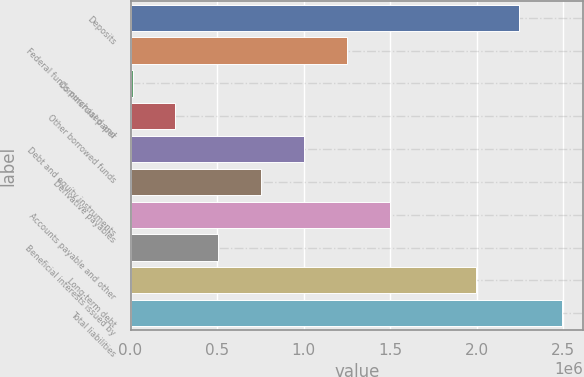<chart> <loc_0><loc_0><loc_500><loc_500><bar_chart><fcel>Deposits<fcel>Federal funds purchased and<fcel>Commercial paper<fcel>Other borrowed funds<fcel>Debt and equity instruments<fcel>Derivative payables<fcel>Accounts payable and other<fcel>Beneficial interests issued by<fcel>Long-term debt<fcel>Total liabilities<nl><fcel>2.24305e+06<fcel>1.25136e+06<fcel>11738<fcel>259661<fcel>1.00343e+06<fcel>755508<fcel>1.49928e+06<fcel>507585<fcel>1.99513e+06<fcel>2.49097e+06<nl></chart> 